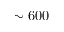<formula> <loc_0><loc_0><loc_500><loc_500>\sim 6 0 0</formula> 